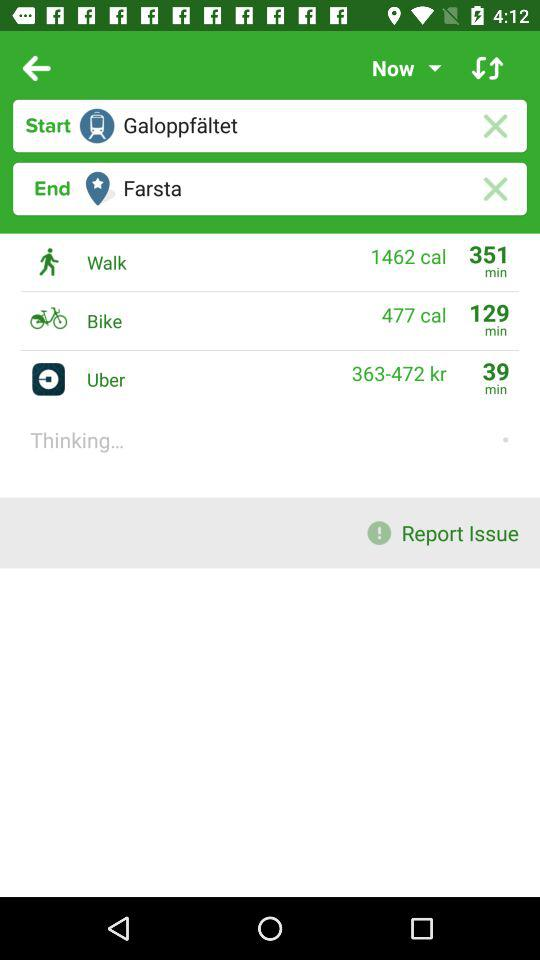477 calories are burned in what ride? 477 calories are burned in a bike ride. 